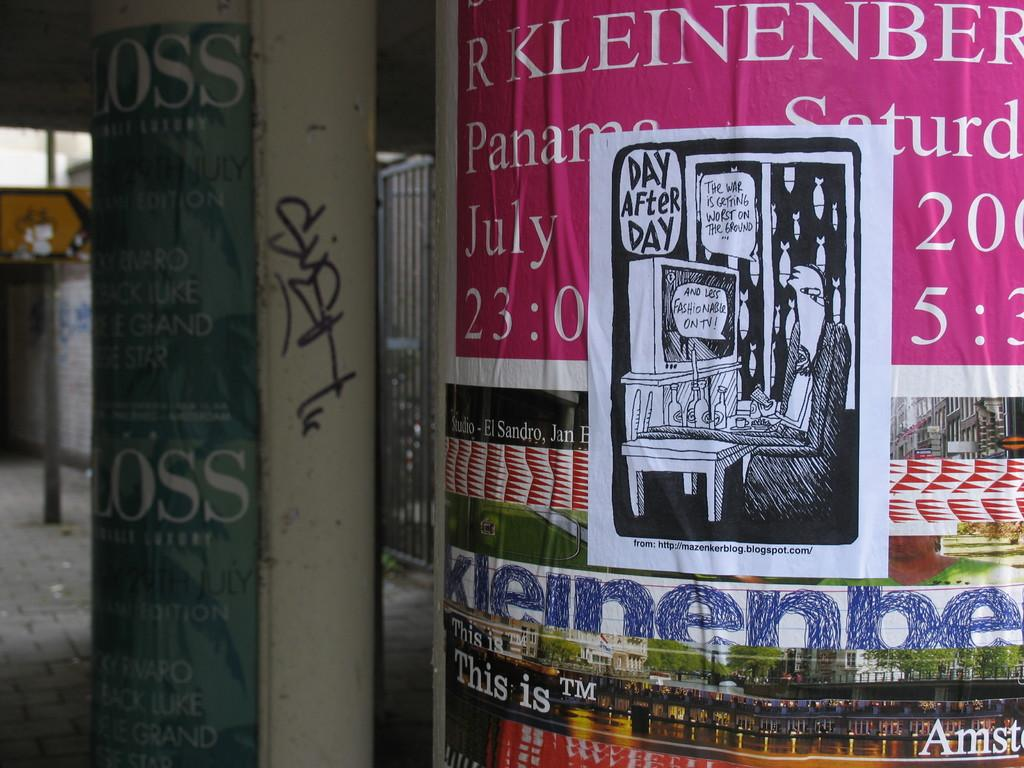<image>
Describe the image concisely. some ads with the name Kleinenber at the top 